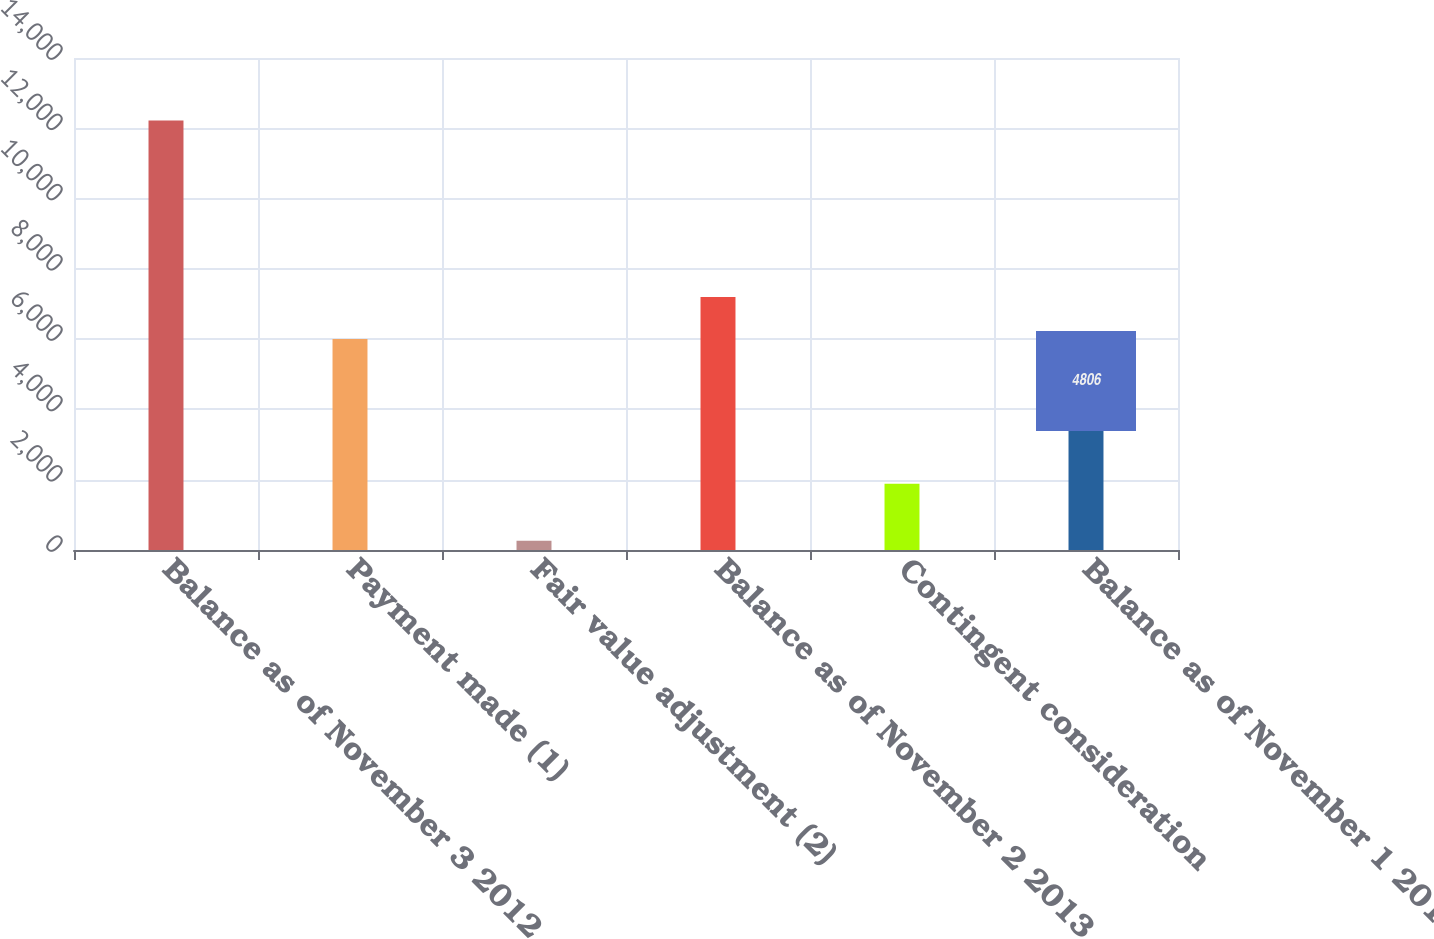<chart> <loc_0><loc_0><loc_500><loc_500><bar_chart><fcel>Balance as of November 3 2012<fcel>Payment made (1)<fcel>Fair value adjustment (2)<fcel>Balance as of November 2 2013<fcel>Contingent consideration<fcel>Balance as of November 1 2014<nl><fcel>12219<fcel>6001.9<fcel>260<fcel>7197.8<fcel>1888<fcel>4806<nl></chart> 